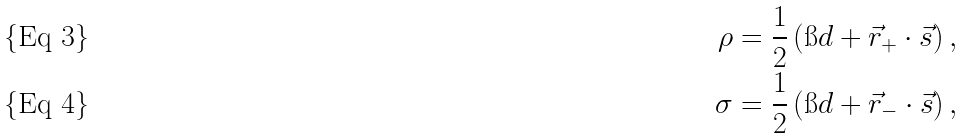Convert formula to latex. <formula><loc_0><loc_0><loc_500><loc_500>\rho & = \frac { 1 } { 2 } \left ( \i d + \vec { r } _ { + } \cdot \vec { s } \right ) , \\ \sigma & = \frac { 1 } { 2 } \left ( \i d + \vec { r } _ { - } \cdot \vec { s } \right ) ,</formula> 